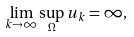Convert formula to latex. <formula><loc_0><loc_0><loc_500><loc_500>\lim _ { k \to \infty } \sup _ { \Omega } u _ { k } = \infty ,</formula> 